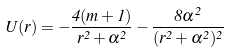<formula> <loc_0><loc_0><loc_500><loc_500>U ( r ) = - \frac { 4 ( m + 1 ) } { r ^ { 2 } + \alpha ^ { 2 } } - \frac { 8 \alpha ^ { 2 } } { ( r ^ { 2 } + \alpha ^ { 2 } ) ^ { 2 } }</formula> 